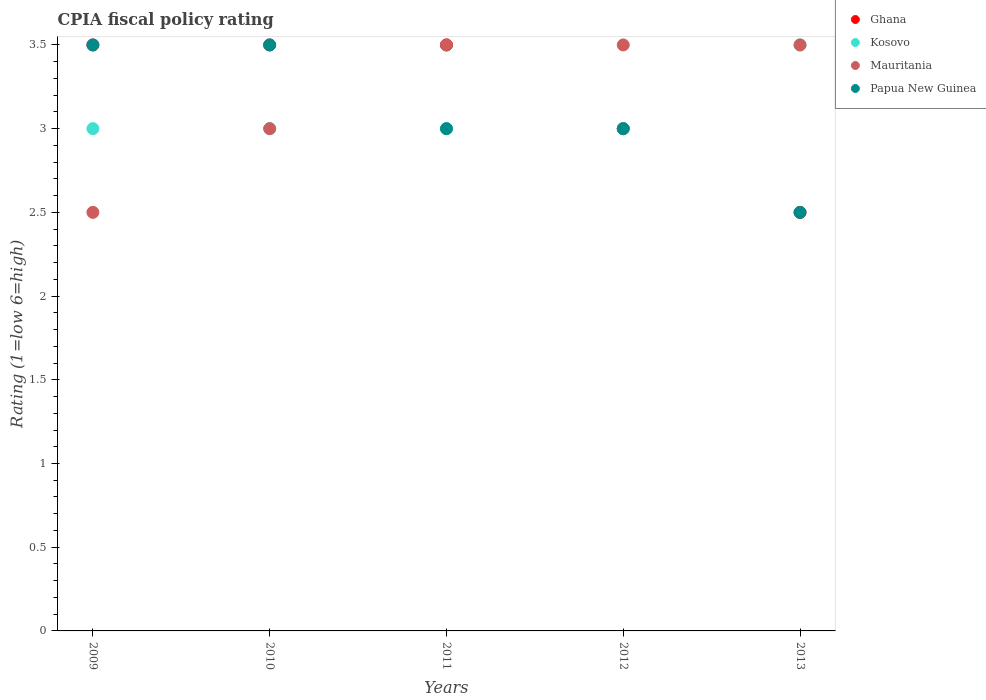How many different coloured dotlines are there?
Your response must be concise. 4. Across all years, what is the maximum CPIA rating in Ghana?
Offer a very short reply. 3.5. In which year was the CPIA rating in Ghana maximum?
Give a very brief answer. 2009. In which year was the CPIA rating in Papua New Guinea minimum?
Provide a short and direct response. 2013. What is the average CPIA rating in Mauritania per year?
Provide a short and direct response. 3.2. In the year 2010, what is the difference between the CPIA rating in Papua New Guinea and CPIA rating in Mauritania?
Offer a terse response. 0.5. In how many years, is the CPIA rating in Kosovo greater than 2?
Give a very brief answer. 5. What is the ratio of the CPIA rating in Papua New Guinea in 2009 to that in 2012?
Offer a terse response. 1.17. Is the CPIA rating in Papua New Guinea in 2009 less than that in 2013?
Keep it short and to the point. No. What is the difference between the highest and the second highest CPIA rating in Mauritania?
Your answer should be compact. 0. What is the difference between the highest and the lowest CPIA rating in Ghana?
Give a very brief answer. 1. In how many years, is the CPIA rating in Ghana greater than the average CPIA rating in Ghana taken over all years?
Give a very brief answer. 3. Is the sum of the CPIA rating in Mauritania in 2009 and 2012 greater than the maximum CPIA rating in Papua New Guinea across all years?
Offer a very short reply. Yes. Is it the case that in every year, the sum of the CPIA rating in Kosovo and CPIA rating in Mauritania  is greater than the CPIA rating in Ghana?
Ensure brevity in your answer.  Yes. Is the CPIA rating in Ghana strictly greater than the CPIA rating in Mauritania over the years?
Your answer should be compact. No. How many years are there in the graph?
Your answer should be very brief. 5. Does the graph contain grids?
Make the answer very short. No. Where does the legend appear in the graph?
Your answer should be very brief. Top right. How are the legend labels stacked?
Offer a terse response. Vertical. What is the title of the graph?
Your response must be concise. CPIA fiscal policy rating. Does "Bhutan" appear as one of the legend labels in the graph?
Offer a very short reply. No. What is the label or title of the X-axis?
Offer a terse response. Years. What is the label or title of the Y-axis?
Provide a succinct answer. Rating (1=low 6=high). What is the Rating (1=low 6=high) in Ghana in 2009?
Your response must be concise. 3.5. What is the Rating (1=low 6=high) in Kosovo in 2009?
Provide a succinct answer. 3. What is the Rating (1=low 6=high) in Papua New Guinea in 2009?
Provide a short and direct response. 3.5. What is the Rating (1=low 6=high) of Ghana in 2010?
Provide a succinct answer. 3.5. What is the Rating (1=low 6=high) in Ghana in 2011?
Make the answer very short. 3.5. What is the Rating (1=low 6=high) of Kosovo in 2011?
Ensure brevity in your answer.  3. What is the Rating (1=low 6=high) of Papua New Guinea in 2011?
Your response must be concise. 3. What is the Rating (1=low 6=high) of Ghana in 2012?
Your response must be concise. 3. What is the Rating (1=low 6=high) of Kosovo in 2012?
Your answer should be very brief. 3. What is the Rating (1=low 6=high) of Mauritania in 2012?
Offer a very short reply. 3.5. Across all years, what is the maximum Rating (1=low 6=high) in Mauritania?
Provide a succinct answer. 3.5. Across all years, what is the minimum Rating (1=low 6=high) in Ghana?
Your answer should be compact. 2.5. Across all years, what is the minimum Rating (1=low 6=high) in Kosovo?
Your response must be concise. 3. What is the total Rating (1=low 6=high) in Kosovo in the graph?
Your response must be concise. 15.5. What is the total Rating (1=low 6=high) in Mauritania in the graph?
Keep it short and to the point. 16. What is the difference between the Rating (1=low 6=high) in Ghana in 2009 and that in 2010?
Keep it short and to the point. 0. What is the difference between the Rating (1=low 6=high) in Kosovo in 2009 and that in 2010?
Make the answer very short. 0. What is the difference between the Rating (1=low 6=high) in Papua New Guinea in 2009 and that in 2010?
Offer a very short reply. 0. What is the difference between the Rating (1=low 6=high) of Ghana in 2009 and that in 2011?
Keep it short and to the point. 0. What is the difference between the Rating (1=low 6=high) in Papua New Guinea in 2009 and that in 2011?
Provide a succinct answer. 0.5. What is the difference between the Rating (1=low 6=high) of Kosovo in 2009 and that in 2012?
Keep it short and to the point. 0. What is the difference between the Rating (1=low 6=high) in Mauritania in 2009 and that in 2013?
Provide a short and direct response. -1. What is the difference between the Rating (1=low 6=high) in Papua New Guinea in 2009 and that in 2013?
Your answer should be compact. 1. What is the difference between the Rating (1=low 6=high) of Papua New Guinea in 2010 and that in 2011?
Provide a short and direct response. 0.5. What is the difference between the Rating (1=low 6=high) of Kosovo in 2010 and that in 2012?
Your answer should be compact. 0. What is the difference between the Rating (1=low 6=high) of Mauritania in 2010 and that in 2012?
Your response must be concise. -0.5. What is the difference between the Rating (1=low 6=high) in Mauritania in 2010 and that in 2013?
Provide a short and direct response. -0.5. What is the difference between the Rating (1=low 6=high) of Kosovo in 2011 and that in 2012?
Offer a terse response. 0. What is the difference between the Rating (1=low 6=high) in Papua New Guinea in 2011 and that in 2012?
Ensure brevity in your answer.  0. What is the difference between the Rating (1=low 6=high) of Mauritania in 2011 and that in 2013?
Make the answer very short. 0. What is the difference between the Rating (1=low 6=high) of Papua New Guinea in 2011 and that in 2013?
Give a very brief answer. 0.5. What is the difference between the Rating (1=low 6=high) of Ghana in 2012 and that in 2013?
Give a very brief answer. 0.5. What is the difference between the Rating (1=low 6=high) in Ghana in 2009 and the Rating (1=low 6=high) in Mauritania in 2010?
Offer a very short reply. 0.5. What is the difference between the Rating (1=low 6=high) of Ghana in 2009 and the Rating (1=low 6=high) of Papua New Guinea in 2010?
Ensure brevity in your answer.  0. What is the difference between the Rating (1=low 6=high) in Mauritania in 2009 and the Rating (1=low 6=high) in Papua New Guinea in 2010?
Provide a succinct answer. -1. What is the difference between the Rating (1=low 6=high) of Ghana in 2009 and the Rating (1=low 6=high) of Mauritania in 2011?
Offer a terse response. 0. What is the difference between the Rating (1=low 6=high) of Mauritania in 2009 and the Rating (1=low 6=high) of Papua New Guinea in 2011?
Keep it short and to the point. -0.5. What is the difference between the Rating (1=low 6=high) in Ghana in 2009 and the Rating (1=low 6=high) in Kosovo in 2012?
Your response must be concise. 0.5. What is the difference between the Rating (1=low 6=high) in Ghana in 2009 and the Rating (1=low 6=high) in Papua New Guinea in 2012?
Offer a terse response. 0.5. What is the difference between the Rating (1=low 6=high) in Kosovo in 2009 and the Rating (1=low 6=high) in Mauritania in 2012?
Offer a terse response. -0.5. What is the difference between the Rating (1=low 6=high) in Mauritania in 2009 and the Rating (1=low 6=high) in Papua New Guinea in 2012?
Provide a succinct answer. -0.5. What is the difference between the Rating (1=low 6=high) in Ghana in 2009 and the Rating (1=low 6=high) in Kosovo in 2013?
Keep it short and to the point. 0. What is the difference between the Rating (1=low 6=high) of Kosovo in 2009 and the Rating (1=low 6=high) of Mauritania in 2013?
Provide a short and direct response. -0.5. What is the difference between the Rating (1=low 6=high) in Mauritania in 2009 and the Rating (1=low 6=high) in Papua New Guinea in 2013?
Provide a short and direct response. 0. What is the difference between the Rating (1=low 6=high) of Ghana in 2010 and the Rating (1=low 6=high) of Mauritania in 2011?
Offer a terse response. 0. What is the difference between the Rating (1=low 6=high) of Ghana in 2010 and the Rating (1=low 6=high) of Papua New Guinea in 2011?
Provide a succinct answer. 0.5. What is the difference between the Rating (1=low 6=high) in Kosovo in 2010 and the Rating (1=low 6=high) in Mauritania in 2011?
Your response must be concise. -0.5. What is the difference between the Rating (1=low 6=high) of Kosovo in 2010 and the Rating (1=low 6=high) of Papua New Guinea in 2011?
Provide a short and direct response. 0. What is the difference between the Rating (1=low 6=high) in Mauritania in 2010 and the Rating (1=low 6=high) in Papua New Guinea in 2011?
Offer a very short reply. 0. What is the difference between the Rating (1=low 6=high) of Ghana in 2010 and the Rating (1=low 6=high) of Kosovo in 2012?
Provide a short and direct response. 0.5. What is the difference between the Rating (1=low 6=high) of Ghana in 2010 and the Rating (1=low 6=high) of Mauritania in 2012?
Your response must be concise. 0. What is the difference between the Rating (1=low 6=high) of Kosovo in 2010 and the Rating (1=low 6=high) of Mauritania in 2012?
Your answer should be compact. -0.5. What is the difference between the Rating (1=low 6=high) of Kosovo in 2010 and the Rating (1=low 6=high) of Papua New Guinea in 2012?
Ensure brevity in your answer.  0. What is the difference between the Rating (1=low 6=high) of Mauritania in 2010 and the Rating (1=low 6=high) of Papua New Guinea in 2012?
Make the answer very short. 0. What is the difference between the Rating (1=low 6=high) in Kosovo in 2010 and the Rating (1=low 6=high) in Mauritania in 2013?
Keep it short and to the point. -0.5. What is the difference between the Rating (1=low 6=high) in Mauritania in 2010 and the Rating (1=low 6=high) in Papua New Guinea in 2013?
Provide a succinct answer. 0.5. What is the difference between the Rating (1=low 6=high) of Kosovo in 2011 and the Rating (1=low 6=high) of Mauritania in 2012?
Your answer should be compact. -0.5. What is the difference between the Rating (1=low 6=high) in Kosovo in 2011 and the Rating (1=low 6=high) in Papua New Guinea in 2012?
Provide a short and direct response. 0. What is the difference between the Rating (1=low 6=high) in Mauritania in 2011 and the Rating (1=low 6=high) in Papua New Guinea in 2012?
Make the answer very short. 0.5. What is the difference between the Rating (1=low 6=high) in Ghana in 2011 and the Rating (1=low 6=high) in Mauritania in 2013?
Offer a terse response. 0. What is the difference between the Rating (1=low 6=high) in Kosovo in 2011 and the Rating (1=low 6=high) in Mauritania in 2013?
Provide a short and direct response. -0.5. What is the difference between the Rating (1=low 6=high) of Ghana in 2012 and the Rating (1=low 6=high) of Kosovo in 2013?
Provide a succinct answer. -0.5. What is the difference between the Rating (1=low 6=high) of Ghana in 2012 and the Rating (1=low 6=high) of Mauritania in 2013?
Give a very brief answer. -0.5. What is the difference between the Rating (1=low 6=high) of Ghana in 2012 and the Rating (1=low 6=high) of Papua New Guinea in 2013?
Your answer should be very brief. 0.5. What is the difference between the Rating (1=low 6=high) in Kosovo in 2012 and the Rating (1=low 6=high) in Mauritania in 2013?
Give a very brief answer. -0.5. What is the average Rating (1=low 6=high) in Ghana per year?
Your response must be concise. 3.2. What is the average Rating (1=low 6=high) of Kosovo per year?
Offer a terse response. 3.1. In the year 2009, what is the difference between the Rating (1=low 6=high) in Kosovo and Rating (1=low 6=high) in Mauritania?
Offer a terse response. 0.5. In the year 2009, what is the difference between the Rating (1=low 6=high) of Mauritania and Rating (1=low 6=high) of Papua New Guinea?
Your answer should be compact. -1. In the year 2010, what is the difference between the Rating (1=low 6=high) of Ghana and Rating (1=low 6=high) of Kosovo?
Your response must be concise. 0.5. In the year 2010, what is the difference between the Rating (1=low 6=high) in Ghana and Rating (1=low 6=high) in Mauritania?
Provide a succinct answer. 0.5. In the year 2010, what is the difference between the Rating (1=low 6=high) of Ghana and Rating (1=low 6=high) of Papua New Guinea?
Ensure brevity in your answer.  0. In the year 2010, what is the difference between the Rating (1=low 6=high) of Kosovo and Rating (1=low 6=high) of Mauritania?
Your answer should be compact. 0. In the year 2010, what is the difference between the Rating (1=low 6=high) of Mauritania and Rating (1=low 6=high) of Papua New Guinea?
Your answer should be compact. -0.5. In the year 2011, what is the difference between the Rating (1=low 6=high) in Ghana and Rating (1=low 6=high) in Kosovo?
Offer a very short reply. 0.5. In the year 2011, what is the difference between the Rating (1=low 6=high) of Kosovo and Rating (1=low 6=high) of Papua New Guinea?
Offer a terse response. 0. In the year 2012, what is the difference between the Rating (1=low 6=high) in Ghana and Rating (1=low 6=high) in Kosovo?
Your response must be concise. 0. In the year 2012, what is the difference between the Rating (1=low 6=high) of Kosovo and Rating (1=low 6=high) of Mauritania?
Keep it short and to the point. -0.5. What is the ratio of the Rating (1=low 6=high) in Ghana in 2009 to that in 2010?
Provide a short and direct response. 1. What is the ratio of the Rating (1=low 6=high) of Kosovo in 2009 to that in 2011?
Provide a succinct answer. 1. What is the ratio of the Rating (1=low 6=high) in Ghana in 2009 to that in 2012?
Your answer should be compact. 1.17. What is the ratio of the Rating (1=low 6=high) in Kosovo in 2009 to that in 2012?
Make the answer very short. 1. What is the ratio of the Rating (1=low 6=high) of Mauritania in 2009 to that in 2012?
Make the answer very short. 0.71. What is the ratio of the Rating (1=low 6=high) of Kosovo in 2009 to that in 2013?
Keep it short and to the point. 0.86. What is the ratio of the Rating (1=low 6=high) in Papua New Guinea in 2009 to that in 2013?
Offer a terse response. 1.4. What is the ratio of the Rating (1=low 6=high) in Kosovo in 2010 to that in 2011?
Offer a very short reply. 1. What is the ratio of the Rating (1=low 6=high) in Mauritania in 2010 to that in 2011?
Keep it short and to the point. 0.86. What is the ratio of the Rating (1=low 6=high) of Papua New Guinea in 2010 to that in 2011?
Your answer should be compact. 1.17. What is the ratio of the Rating (1=low 6=high) of Ghana in 2010 to that in 2012?
Give a very brief answer. 1.17. What is the ratio of the Rating (1=low 6=high) of Kosovo in 2010 to that in 2012?
Ensure brevity in your answer.  1. What is the ratio of the Rating (1=low 6=high) of Mauritania in 2010 to that in 2012?
Ensure brevity in your answer.  0.86. What is the ratio of the Rating (1=low 6=high) in Papua New Guinea in 2010 to that in 2012?
Your answer should be very brief. 1.17. What is the ratio of the Rating (1=low 6=high) in Ghana in 2010 to that in 2013?
Give a very brief answer. 1.4. What is the ratio of the Rating (1=low 6=high) of Mauritania in 2010 to that in 2013?
Provide a short and direct response. 0.86. What is the ratio of the Rating (1=low 6=high) of Papua New Guinea in 2010 to that in 2013?
Make the answer very short. 1.4. What is the ratio of the Rating (1=low 6=high) in Kosovo in 2011 to that in 2012?
Your answer should be compact. 1. What is the ratio of the Rating (1=low 6=high) of Papua New Guinea in 2011 to that in 2012?
Provide a succinct answer. 1. What is the ratio of the Rating (1=low 6=high) of Ghana in 2011 to that in 2013?
Offer a very short reply. 1.4. What is the ratio of the Rating (1=low 6=high) of Kosovo in 2011 to that in 2013?
Ensure brevity in your answer.  0.86. What is the ratio of the Rating (1=low 6=high) in Ghana in 2012 to that in 2013?
Give a very brief answer. 1.2. What is the difference between the highest and the lowest Rating (1=low 6=high) in Ghana?
Your response must be concise. 1. What is the difference between the highest and the lowest Rating (1=low 6=high) in Kosovo?
Your response must be concise. 0.5. What is the difference between the highest and the lowest Rating (1=low 6=high) of Papua New Guinea?
Offer a very short reply. 1. 